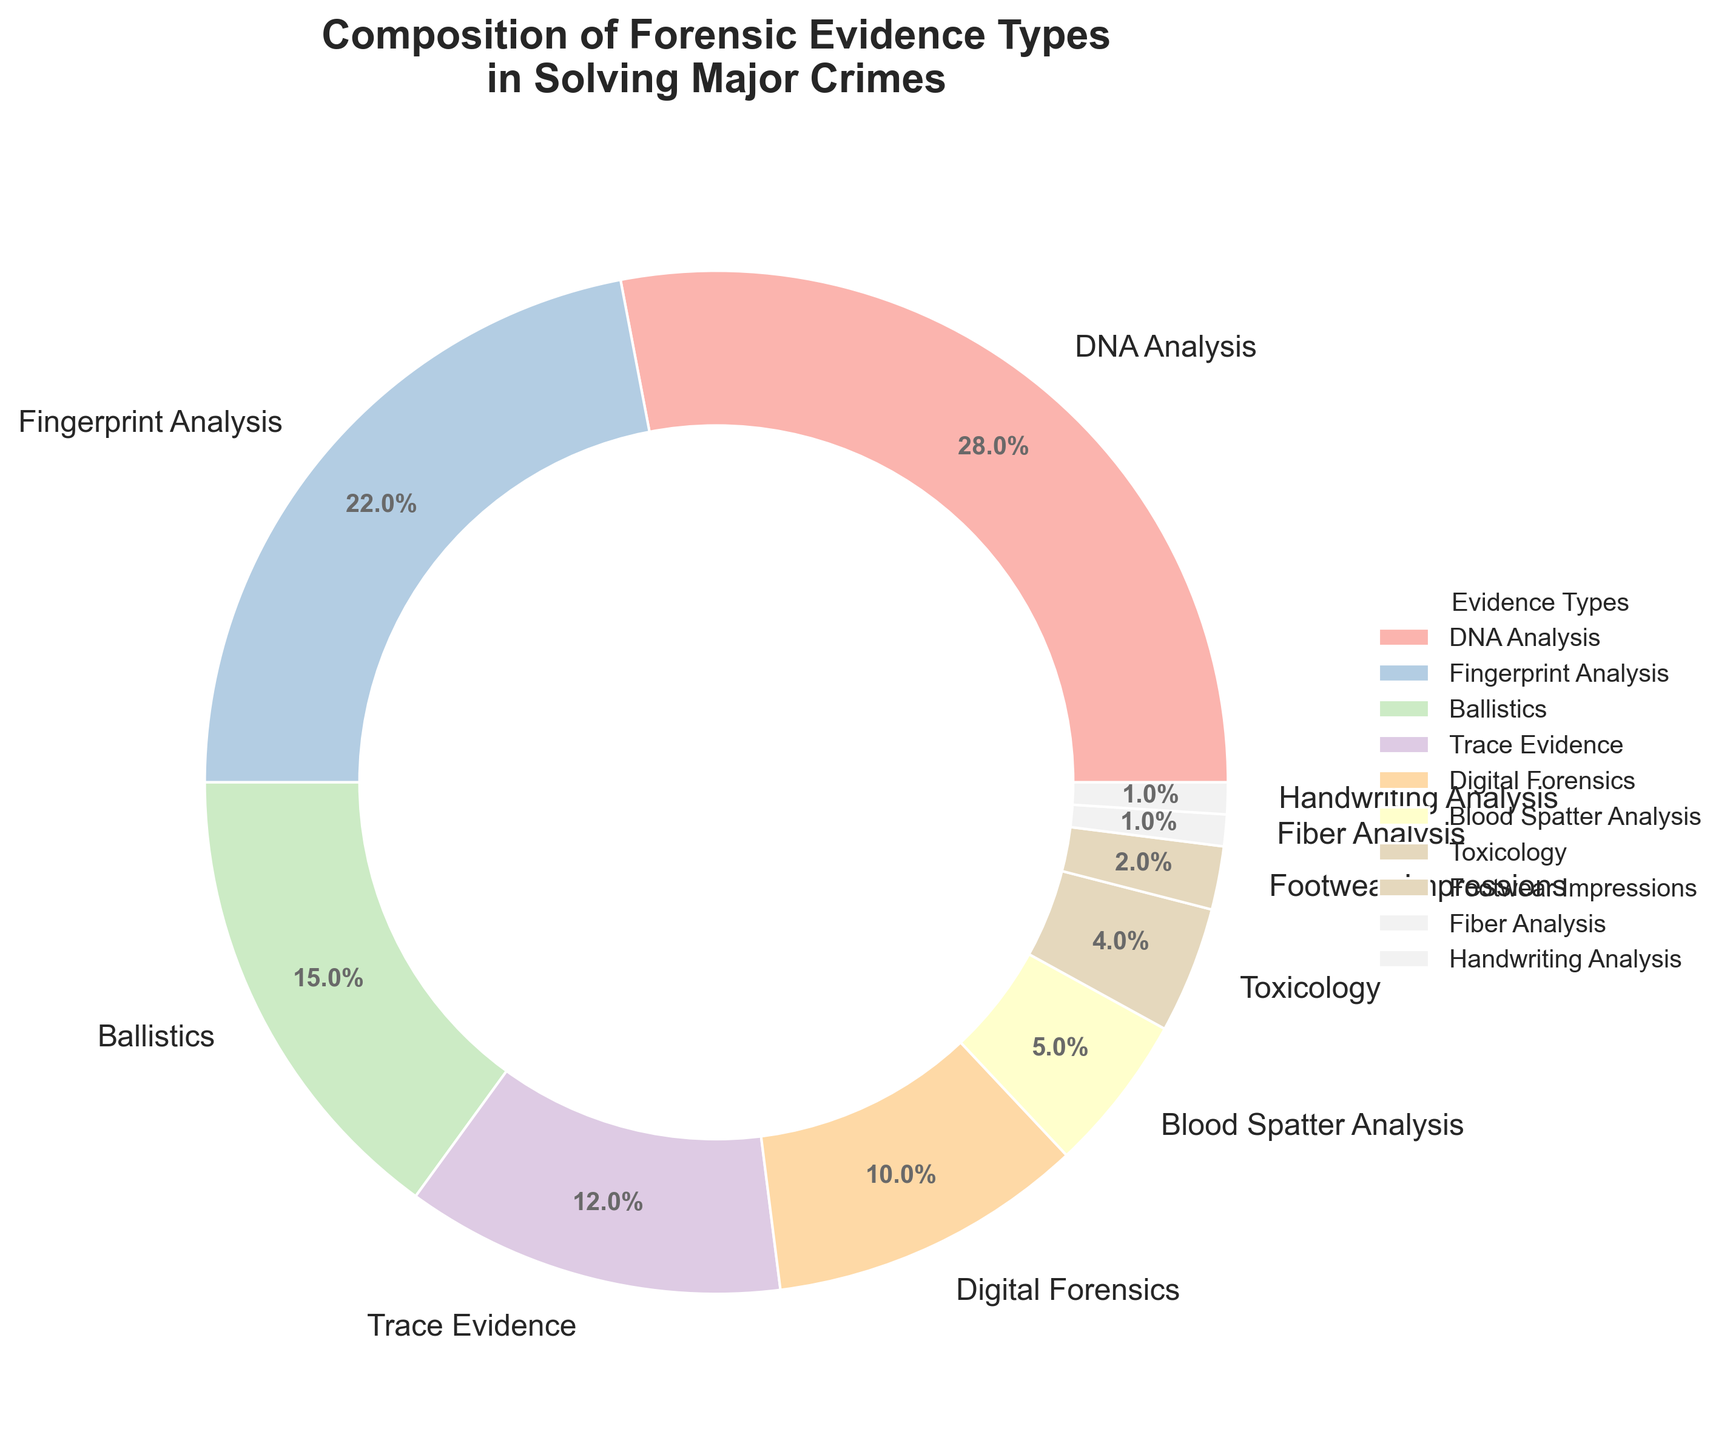Which forensic evidence type has the highest percentage? The pie chart shows the percentage distribution of various forensic evidence types. By looking at the chart, the evidence type with the largest section is DNA Analysis.
Answer: DNA Analysis What is the combined percentage of Fingerprint Analysis and Ballistics? By examining the individual percentages in the pie chart, Fingerprint Analysis is 22% and Ballistics is 15%. Adding these percentages together gives 22% + 15% = 37%.
Answer: 37% Is Trace Evidence more frequently used than Digital Forensics? By comparing the two slices of the pie chart, Trace Evidence has a 12% share while Digital Forensics has a 10% share. Since 12% is greater than 10%, Trace Evidence is more frequently used than Digital Forensics.
Answer: Yes What is the difference in percentage between Blood Spatter Analysis and Toxicology? According to the pie chart, Blood Spatter Analysis holds 5% and Toxicology holds 4%. The difference is calculated by subtracting the smaller percentage from the larger one, which is 5% - 4% = 1%.
Answer: 1% Which evidence types have a share less than 5%? Observing the pie chart, the evidence types with a share less than 5% are Toxicology (4%), Footwear Impressions (2%), Fiber Analysis (1%), and Handwriting Analysis (1%).
Answer: Toxicology, Footwear Impressions, Fiber Analysis, Handwriting Analysis What percentage of the pie chart is made up of DNA Analysis, Fingerprint Analysis, and Ballistics combined? From the pie chart, DNA Analysis accounts for 28%, Fingerprint Analysis for 22% and Ballistics for 15%. Adding these together gives 28% + 22% + 15% = 65%.
Answer: 65% Which evidence type occupies the second largest portion of the pie chart? By looking at the segments of the pie chart, the second largest portion after DNA Analysis (28%) is Fingerprint Analysis (22%).
Answer: Fingerprint Analysis How does the percentage of Ballistics compare to the combined percentage of Blood Spatter Analysis and Toxicology? Ballistics holds 15% in the pie chart. Blood Spatter Analysis and Toxicology combined give 5% + 4% = 9%. Since 15% is greater than 9%, Ballistics has a larger percentage than the combined share of Blood Spatter Analysis and Toxicology.
Answer: Ballistics is greater What fraction of the pie is made up by Fiber Analysis and Handwriting Analysis together? Each of these evidence types holds 1% of the chart. Adding them together, the total percentage is 1% + 1% = 2%. Converting this percentage to a fraction, 2% equals 2/100 or simplified, 1/50 of the pie.
Answer: 1/50 of the pie 